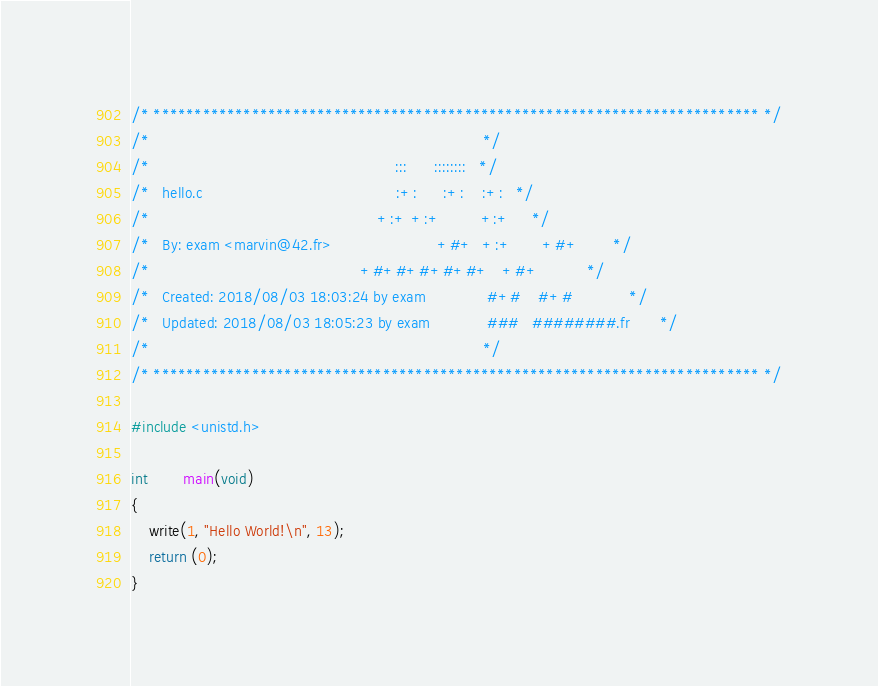<code> <loc_0><loc_0><loc_500><loc_500><_C_>/* ************************************************************************** */
/*                                                                            */
/*                                                        :::      ::::::::   */
/*   hello.c                                            :+:      :+:    :+:   */
/*                                                    +:+ +:+         +:+     */
/*   By: exam <marvin@42.fr>                        +#+  +:+       +#+        */
/*                                                +#+#+#+#+#+   +#+           */
/*   Created: 2018/08/03 18:03:24 by exam              #+#    #+#             */
/*   Updated: 2018/08/03 18:05:23 by exam             ###   ########.fr       */
/*                                                                            */
/* ************************************************************************** */

#include <unistd.h>

int		main(void)
{
	write(1, "Hello World!\n", 13);
	return (0);
}
</code> 